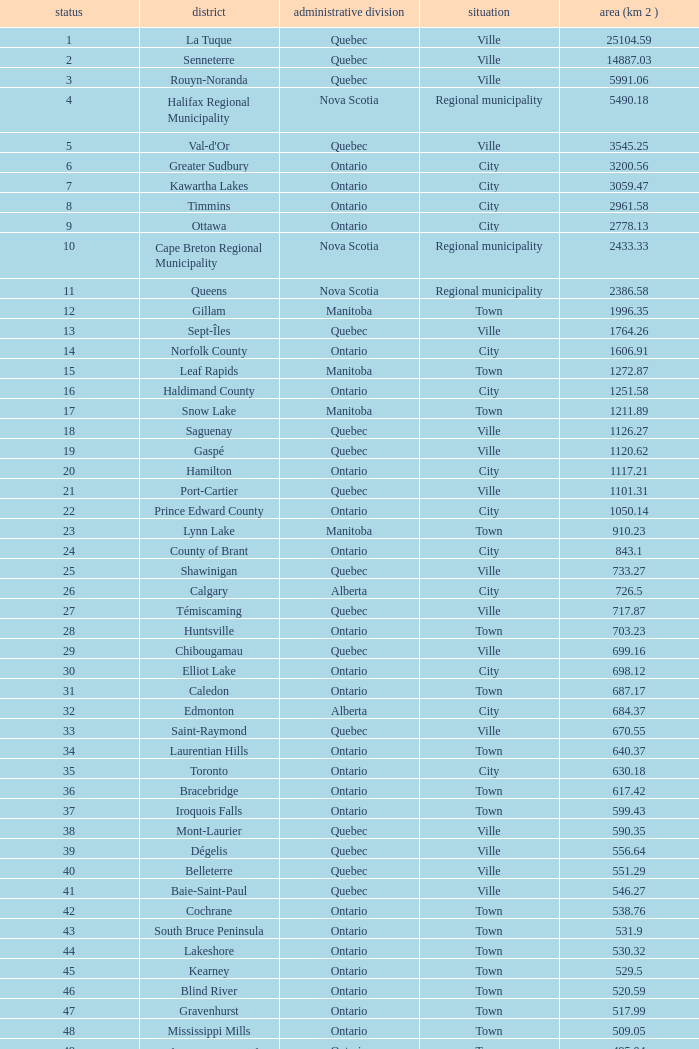What is the total Rank that has a Municipality of Winnipeg, an Area (KM 2) that's larger than 464.01? None. 